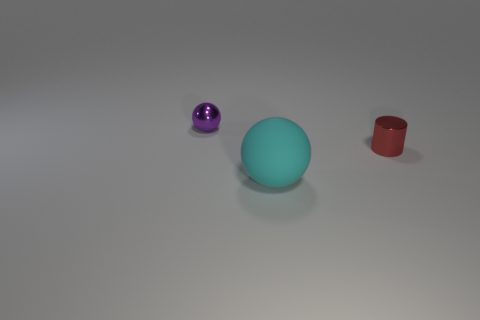Add 2 large brown cylinders. How many objects exist? 5 Subtract all spheres. How many objects are left? 1 Subtract all green cylinders. Subtract all blue blocks. How many cylinders are left? 1 Subtract all small gray cylinders. Subtract all tiny red metallic cylinders. How many objects are left? 2 Add 2 matte things. How many matte things are left? 3 Add 1 small red matte balls. How many small red matte balls exist? 1 Subtract 0 gray blocks. How many objects are left? 3 Subtract 1 spheres. How many spheres are left? 1 